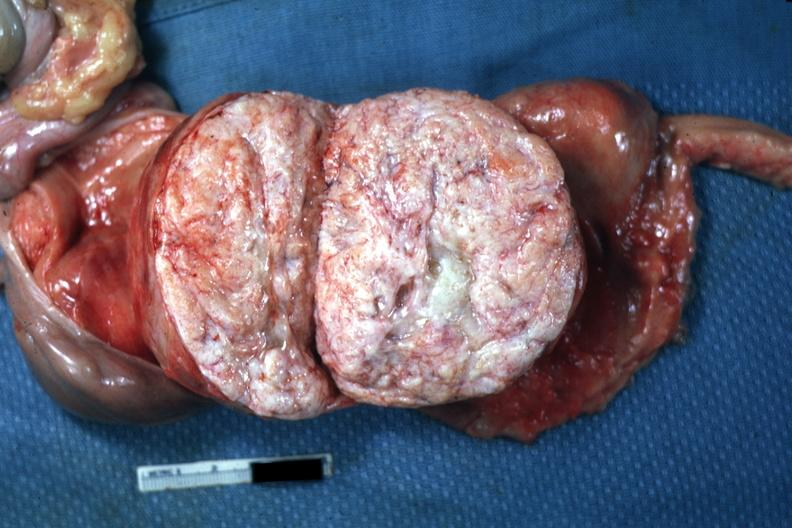s lesion present?
Answer the question using a single word or phrase. No 